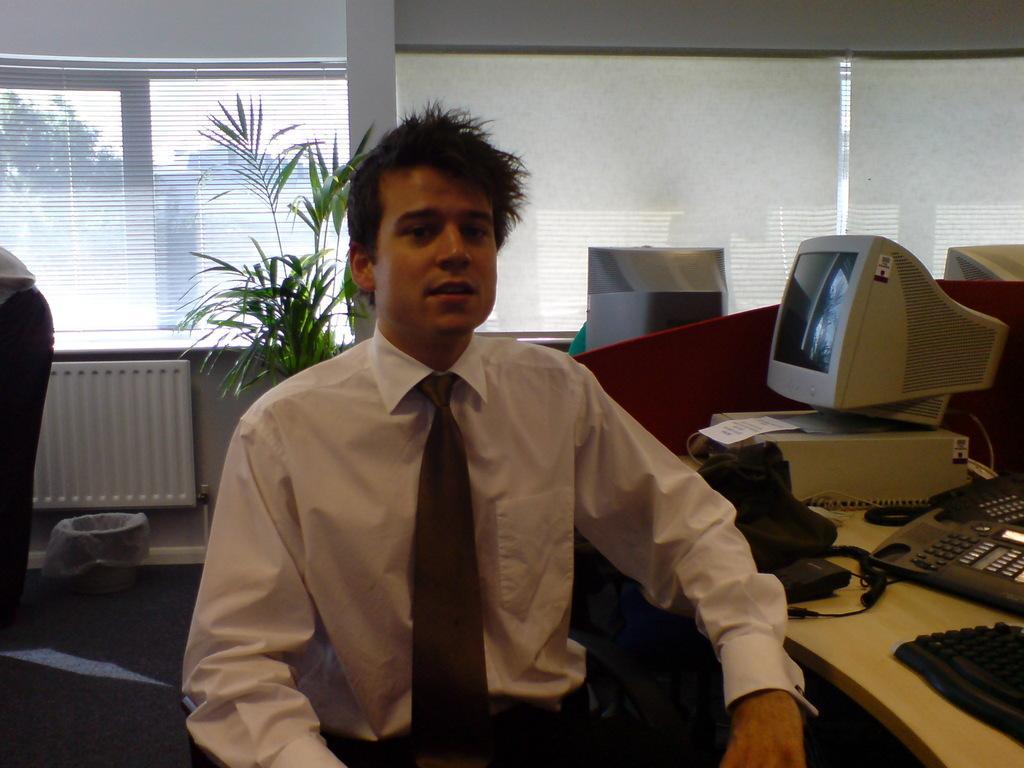Describe this image in one or two sentences. This picture describes about a man seated on the chair, besides to him we can see telephone, key board and monitor on the table, in the background we can see plant and couple of trees. Besides to him a man is standing. 